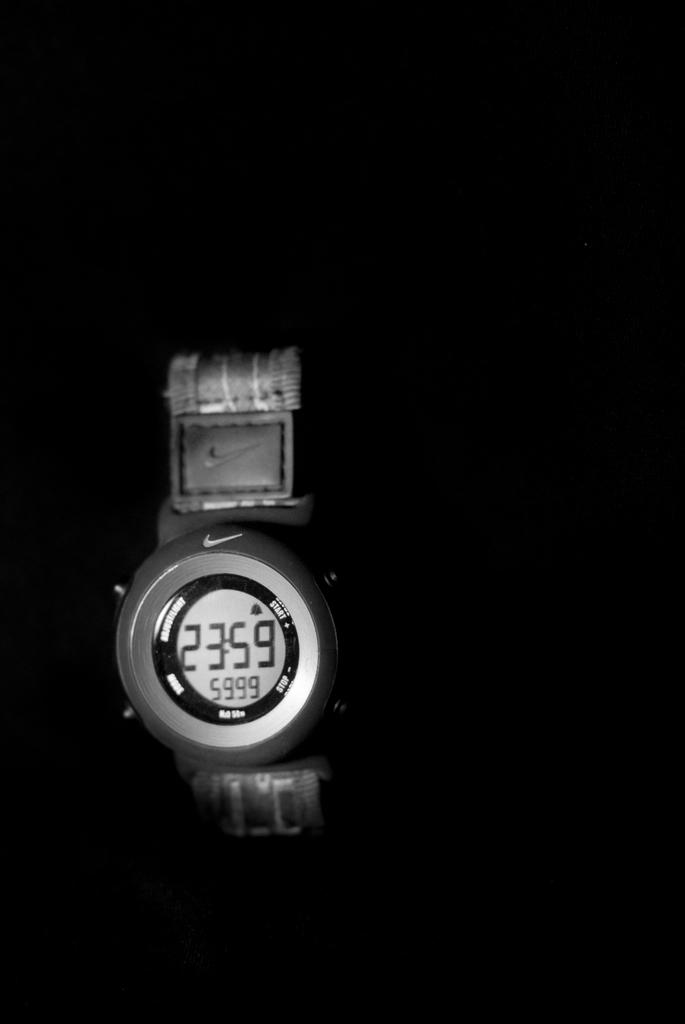What time is it?
Keep it short and to the point. 23:59. Does the timepiece read one minute before midnight?
Your response must be concise. Yes. 